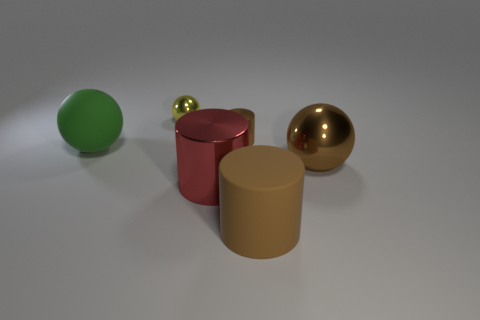Subtract all metallic cylinders. How many cylinders are left? 1 Subtract 1 balls. How many balls are left? 2 Add 3 small yellow balls. How many objects exist? 9 Subtract 0 cyan cylinders. How many objects are left? 6 Subtract all big blue objects. Subtract all red cylinders. How many objects are left? 5 Add 2 big brown balls. How many big brown balls are left? 3 Add 4 yellow metallic balls. How many yellow metallic balls exist? 5 